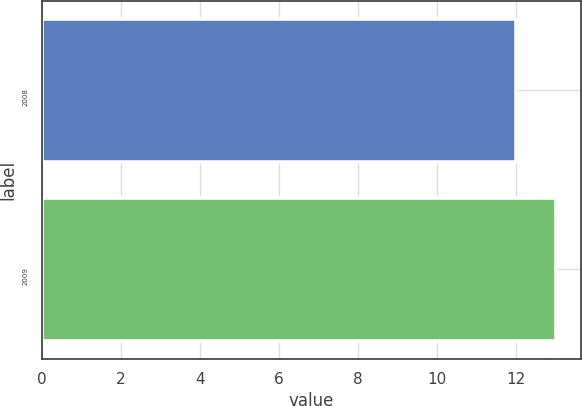Convert chart to OTSL. <chart><loc_0><loc_0><loc_500><loc_500><bar_chart><fcel>2008<fcel>2009<nl><fcel>12<fcel>13<nl></chart> 